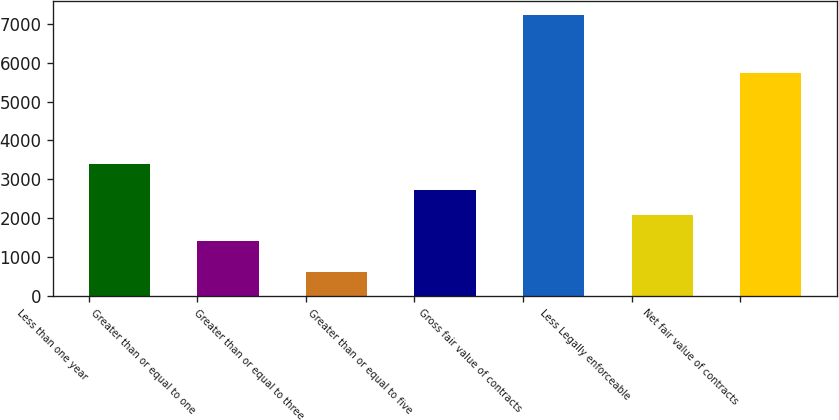<chart> <loc_0><loc_0><loc_500><loc_500><bar_chart><fcel>Less than one year<fcel>Greater than or equal to one<fcel>Greater than or equal to three<fcel>Greater than or equal to five<fcel>Gross fair value of contracts<fcel>Less Legally enforceable<fcel>Net fair value of contracts<nl><fcel>3396.8<fcel>1418<fcel>625<fcel>2737.2<fcel>7221<fcel>2077.6<fcel>5741<nl></chart> 